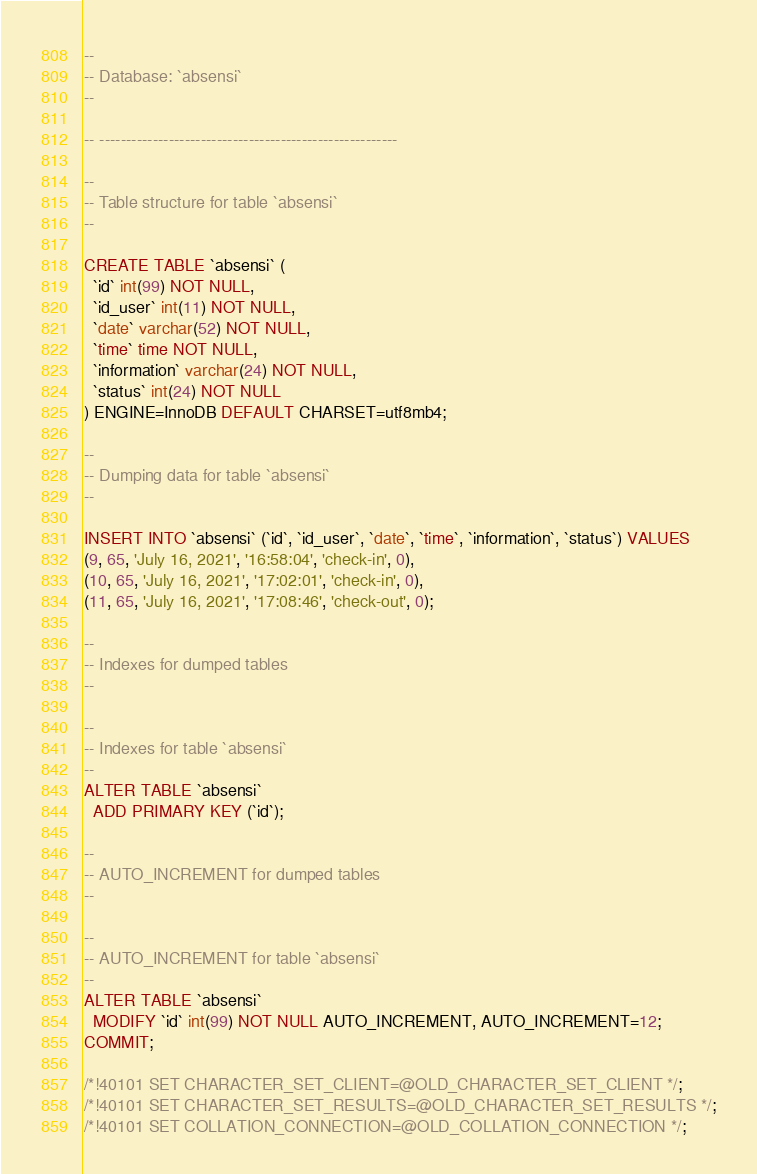<code> <loc_0><loc_0><loc_500><loc_500><_SQL_>
--
-- Database: `absensi`
--

-- --------------------------------------------------------

--
-- Table structure for table `absensi`
--

CREATE TABLE `absensi` (
  `id` int(99) NOT NULL,
  `id_user` int(11) NOT NULL,
  `date` varchar(52) NOT NULL,
  `time` time NOT NULL,
  `information` varchar(24) NOT NULL,
  `status` int(24) NOT NULL
) ENGINE=InnoDB DEFAULT CHARSET=utf8mb4;

--
-- Dumping data for table `absensi`
--

INSERT INTO `absensi` (`id`, `id_user`, `date`, `time`, `information`, `status`) VALUES
(9, 65, 'July 16, 2021', '16:58:04', 'check-in', 0),
(10, 65, 'July 16, 2021', '17:02:01', 'check-in', 0),
(11, 65, 'July 16, 2021', '17:08:46', 'check-out', 0);

--
-- Indexes for dumped tables
--

--
-- Indexes for table `absensi`
--
ALTER TABLE `absensi`
  ADD PRIMARY KEY (`id`);

--
-- AUTO_INCREMENT for dumped tables
--

--
-- AUTO_INCREMENT for table `absensi`
--
ALTER TABLE `absensi`
  MODIFY `id` int(99) NOT NULL AUTO_INCREMENT, AUTO_INCREMENT=12;
COMMIT;

/*!40101 SET CHARACTER_SET_CLIENT=@OLD_CHARACTER_SET_CLIENT */;
/*!40101 SET CHARACTER_SET_RESULTS=@OLD_CHARACTER_SET_RESULTS */;
/*!40101 SET COLLATION_CONNECTION=@OLD_COLLATION_CONNECTION */;
</code> 